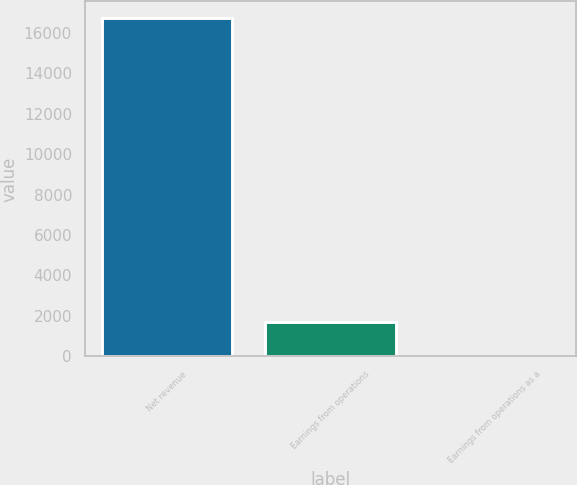Convert chart to OTSL. <chart><loc_0><loc_0><loc_500><loc_500><bar_chart><fcel>Net revenue<fcel>Earnings from operations<fcel>Earnings from operations as a<nl><fcel>16717<fcel>1676.02<fcel>4.8<nl></chart> 